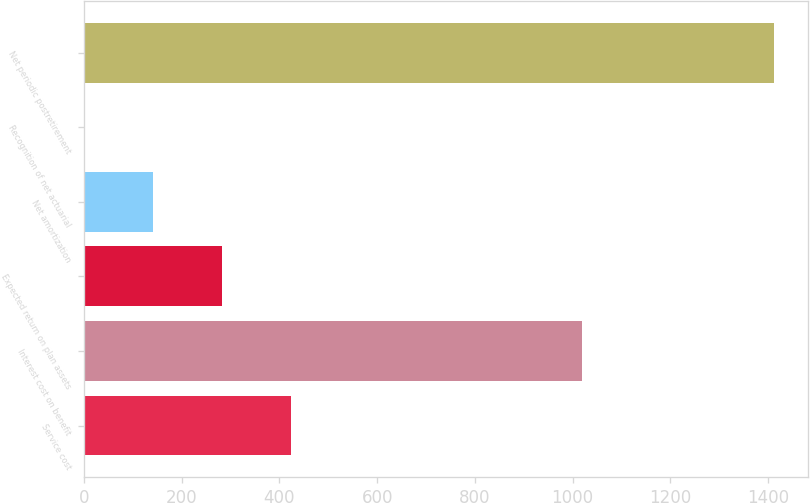<chart> <loc_0><loc_0><loc_500><loc_500><bar_chart><fcel>Service cost<fcel>Interest cost on benefit<fcel>Expected return on plan assets<fcel>Net amortization<fcel>Recognition of net actuarial<fcel>Net periodic postretirement<nl><fcel>423.9<fcel>1020<fcel>282.75<fcel>141.6<fcel>0.45<fcel>1412<nl></chart> 